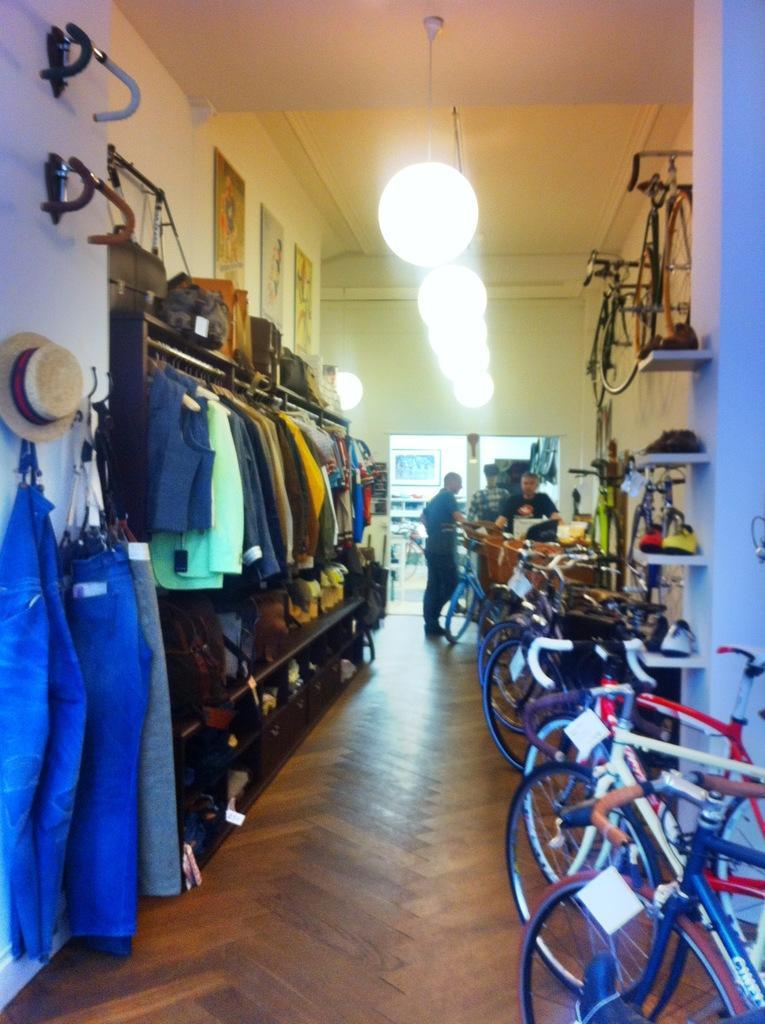How would you summarize this image in a sentence or two? In the center of the image we can see some persons standing. In the right side of the image we can see group of bicycles placed on the ground, some shoes placed on shelves. In the left side of the image we can see a hat ,handles and some clothes on the wall, we can also see bags and some objects place on surface. In the background we can see some photo frames on the wall and some lights on roof. 